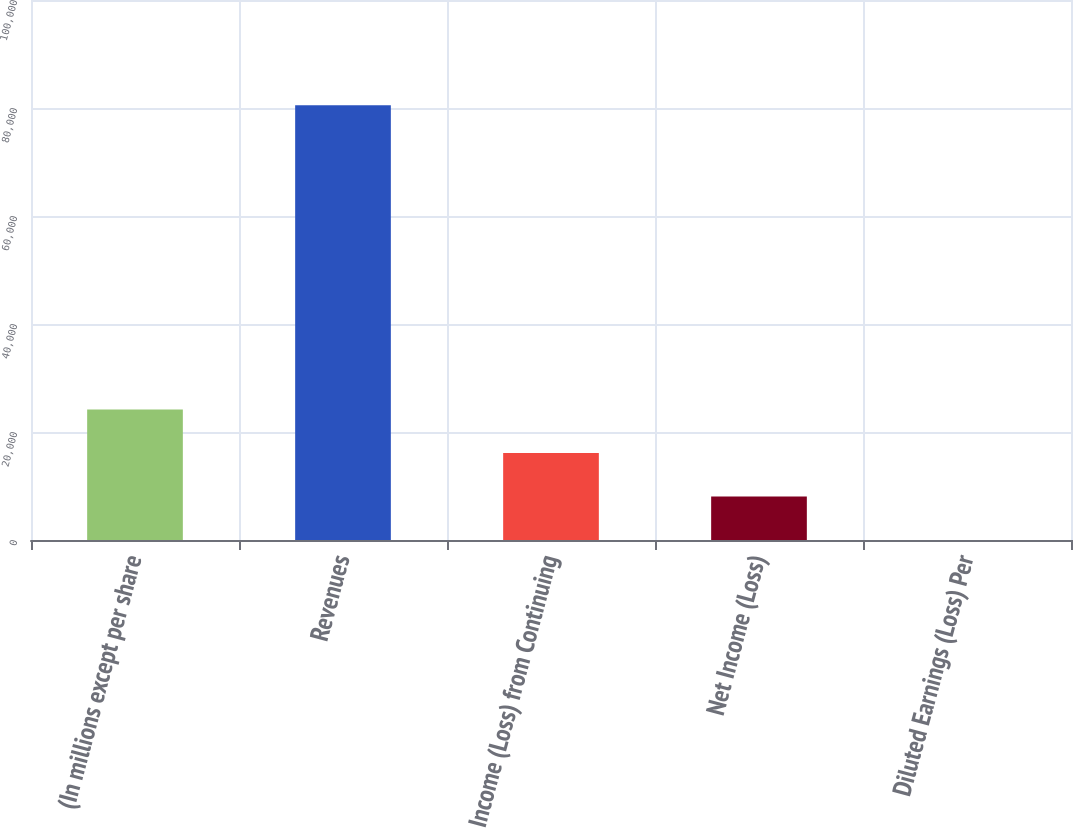Convert chart. <chart><loc_0><loc_0><loc_500><loc_500><bar_chart><fcel>(In millions except per share<fcel>Revenues<fcel>Income (Loss) from Continuing<fcel>Net Income (Loss)<fcel>Diluted Earnings (Loss) Per<nl><fcel>24154.8<fcel>80514.6<fcel>16103.4<fcel>8051.94<fcel>0.53<nl></chart> 